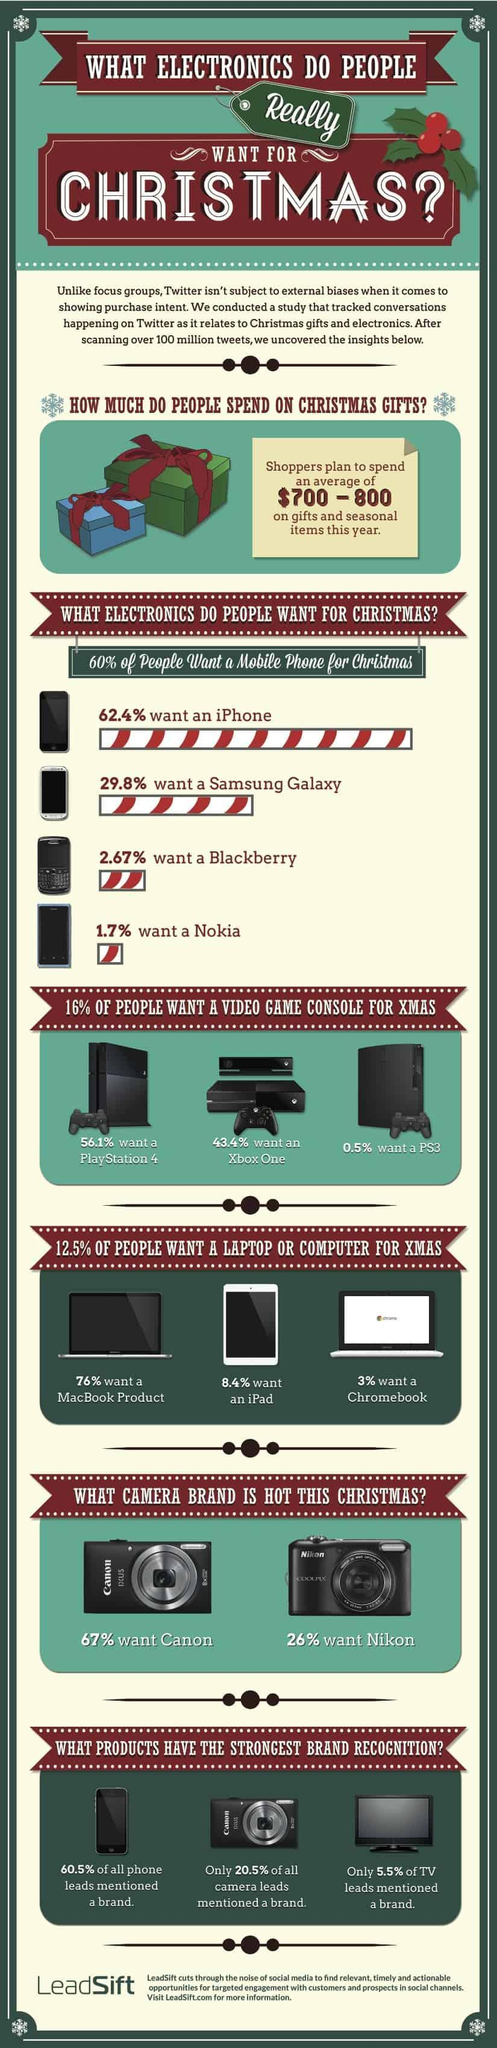What percent of the people do not need a Chromebook for Christmas?
Answer the question with a short phrase. 97% Which phone is most wanted by the people for Christmas? iPhone What percent of people want a Xbox One for the Christmas? 43.4% Which phone is least wanted by the people for Christmas? Nokia What percent of people want a MacBook product for the Christmas? 76% What percentage of people wants a iPad for the Christmas? 8.4% 